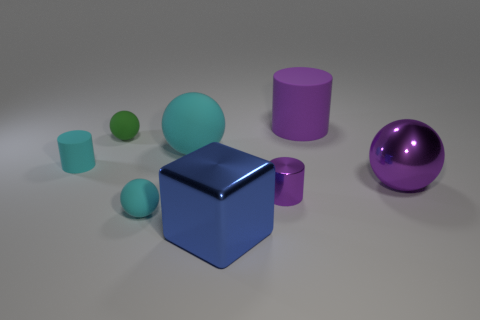Add 2 green things. How many objects exist? 10 Subtract all cylinders. How many objects are left? 5 Subtract 0 yellow cubes. How many objects are left? 8 Subtract all brown metal things. Subtract all tiny cylinders. How many objects are left? 6 Add 4 big shiny objects. How many big shiny objects are left? 6 Add 7 big matte balls. How many big matte balls exist? 8 